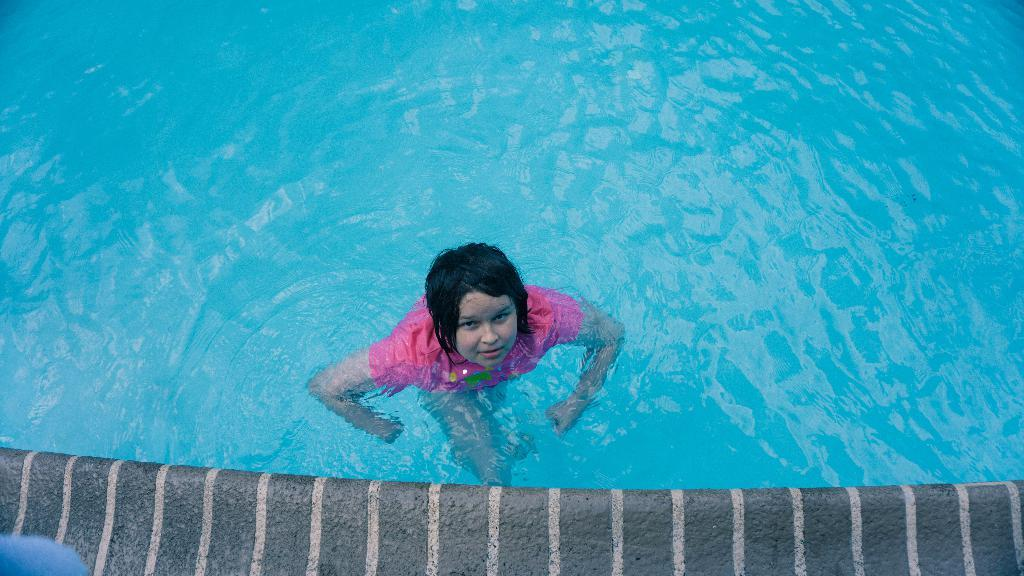What is the person in the image doing? There is a person in the water in the image. Can you describe the person's activity in the water? The provided facts do not specify the person's activity in the water, but they are in the water. What might the person be doing in the water? The person might be swimming, wading, or simply standing in the water. What type of pest can be seen crawling on the person's shoulder in the image? There is no pest visible on the person's shoulder in the image. 